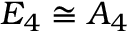<formula> <loc_0><loc_0><loc_500><loc_500>E _ { 4 } \cong A _ { 4 }</formula> 